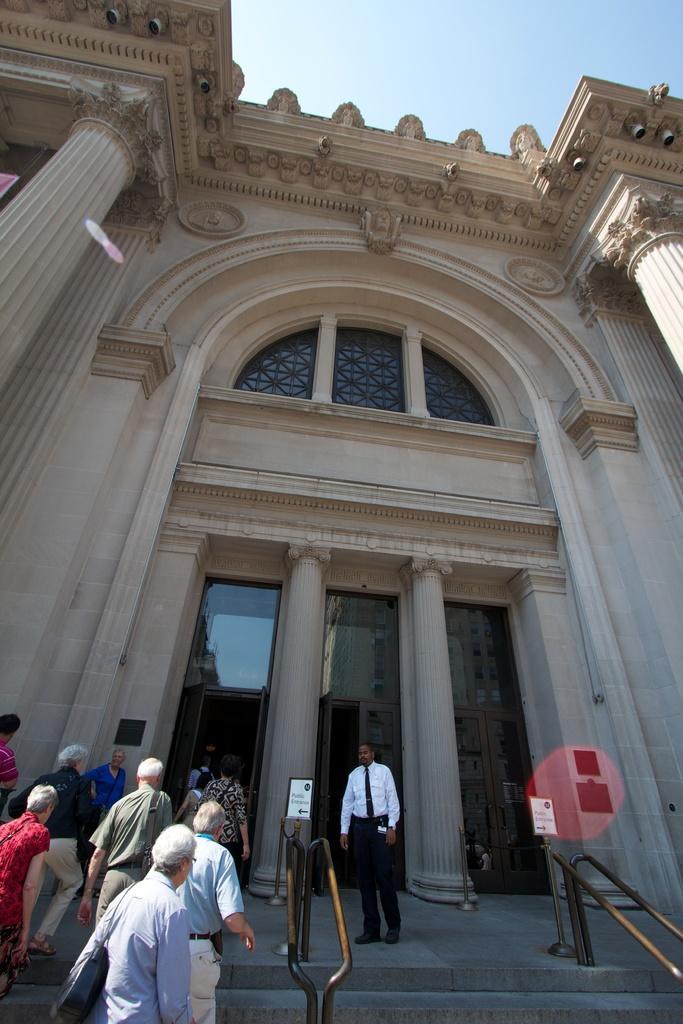Please provide a concise description of this image. In this picture I can observe cream color building. There are some people on the stairs. In the background there is a sky. 